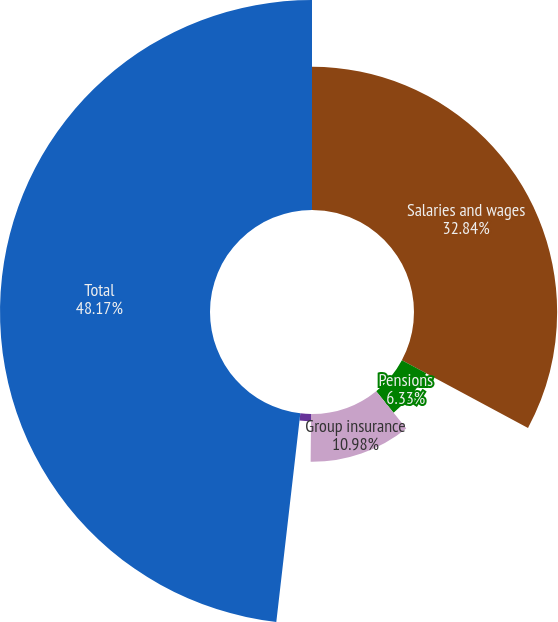Convert chart to OTSL. <chart><loc_0><loc_0><loc_500><loc_500><pie_chart><fcel>Salaries and wages<fcel>Pensions<fcel>Group insurance<fcel>Other benefits<fcel>Total<nl><fcel>32.84%<fcel>6.33%<fcel>10.98%<fcel>1.68%<fcel>48.18%<nl></chart> 